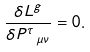<formula> <loc_0><loc_0><loc_500><loc_500>\frac { \delta L ^ { g } } { \delta P ^ { \tau } _ { \ \mu \nu } } = 0 .</formula> 